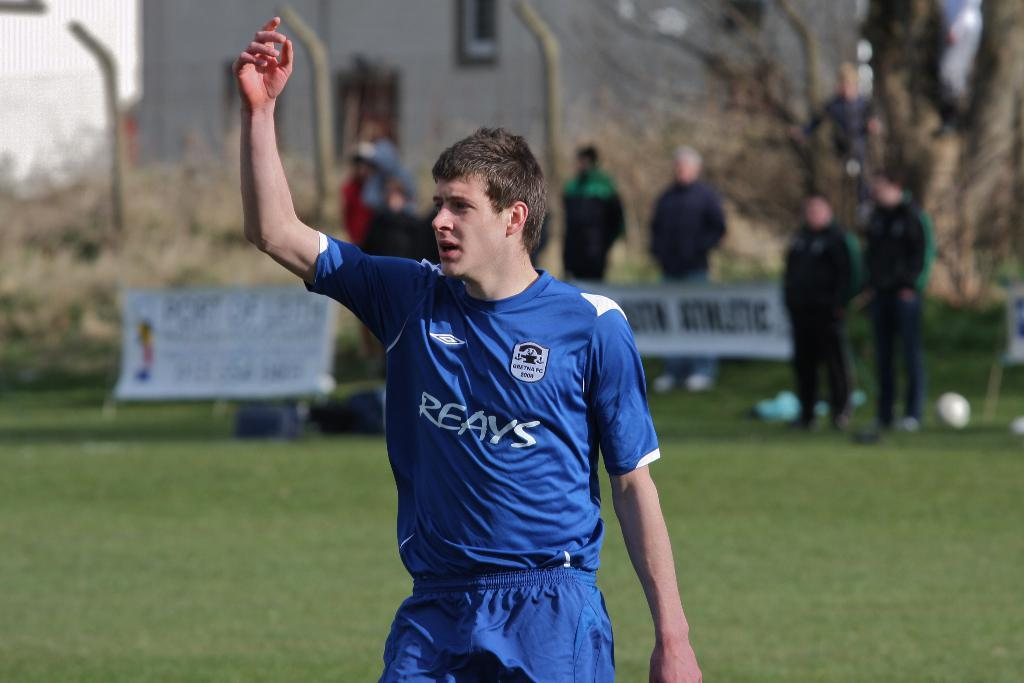<image>
Render a clear and concise summary of the photo. A soccer player in a Reays jersey raises his hand. 